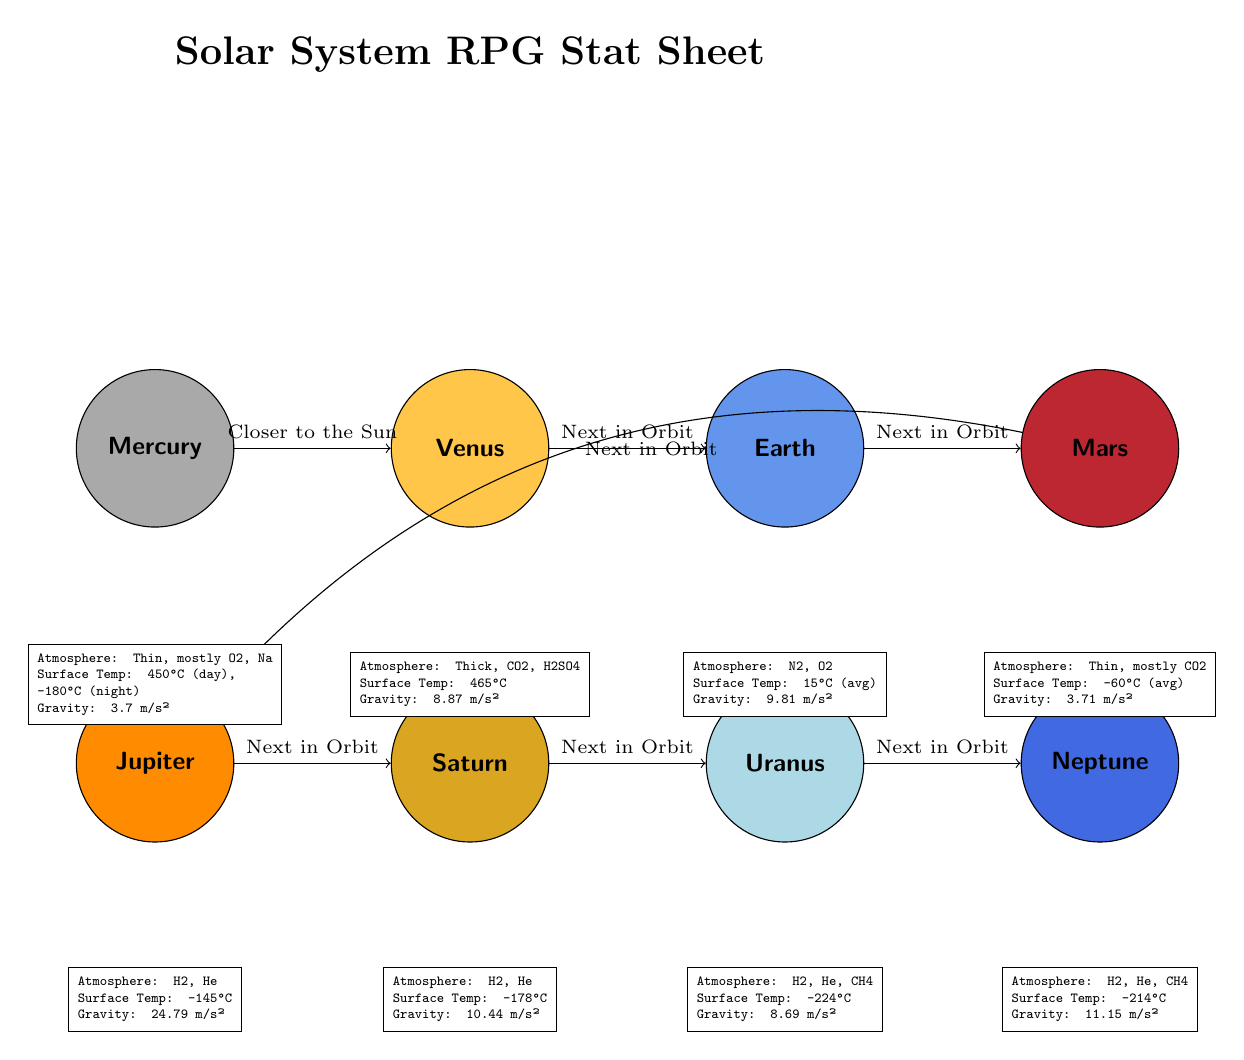What planet has the thickest atmosphere? By looking at the atmosphere descriptions in the attributes section of each planet, Venus is identified as having a thick atmosphere composed of CO2 and H2SO4.
Answer: Venus What is the average surface temperature of Earth? The attributes for Earth indicate an average surface temperature of 15°C. This is derived directly from the provided information in the diagram.
Answer: 15°C How many planets are listed in the diagram? The diagram visually shows eight different planets along a linear sequence, confirming that there are eight total.
Answer: 8 What is the gravitational pull of Jupiter? Referring to the gravity value listed below Jupiter in the diagram, it shows that Jupiter has a gravitational pull of 24.79 m/s².
Answer: 24.79 m/s² Which planet is closest to the Sun? The diagram clearly indicates that Mercury is positioned as the first planet in the sequence, establishing its proximity to the Sun.
Answer: Mercury What is the surface temperature of Mars? The attributes for Mars specify a surface temperature of -60°C on average, as indicated in the diagram.
Answer: -60°C Which two planets share the same atmospheric components? By comparing the atmosphere descriptions, Uranus and Neptune are noted to both have H2, He, and CH4 in their atmospheric compositions.
Answer: Uranus and Neptune What is the surface temperature range for Mercury? The diagram shows two values for surface temperature: 450°C during the day and -180°C at night. These values demonstrate the extreme temperature fluctuations on Mercury.
Answer: 450°C (day), -180°C (night) Which planet has the least gravitational pull? Looking at the gravity values in the diagram, Mercury shows the least gravitational pull at 3.7 m/s², comparing it with others.
Answer: 3.7 m/s² 